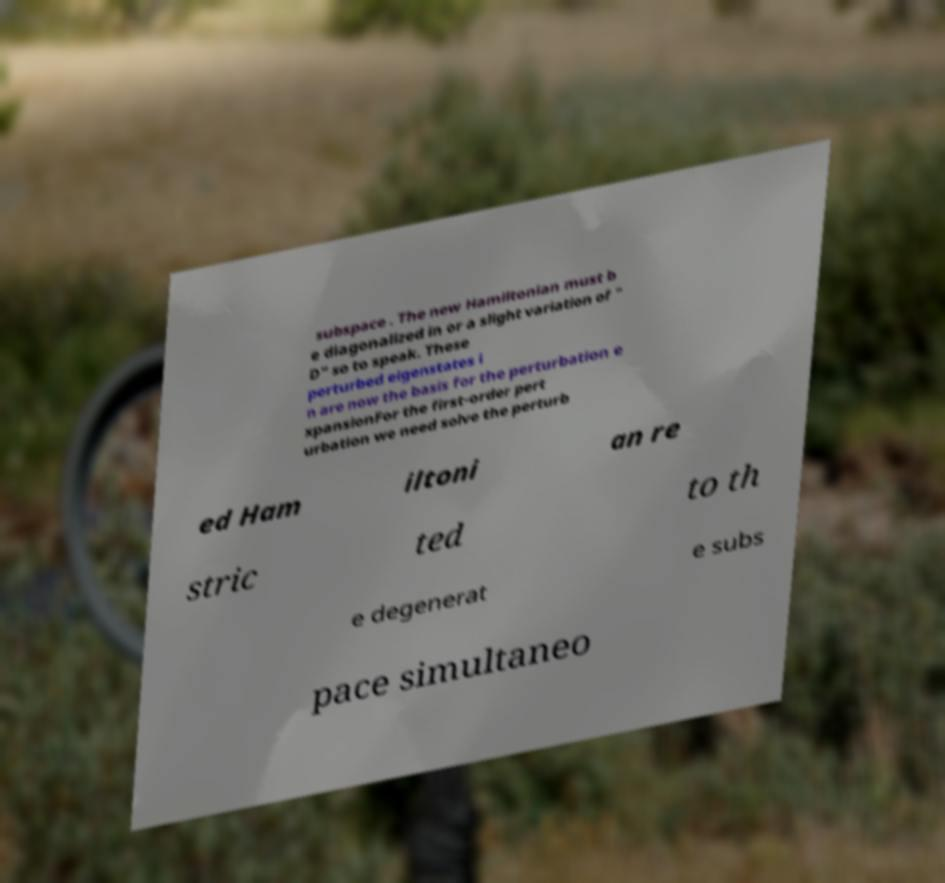I need the written content from this picture converted into text. Can you do that? subspace . The new Hamiltonian must b e diagonalized in or a slight variation of " D" so to speak. These perturbed eigenstates i n are now the basis for the perturbation e xpansionFor the first-order pert urbation we need solve the perturb ed Ham iltoni an re stric ted to th e degenerat e subs pace simultaneo 